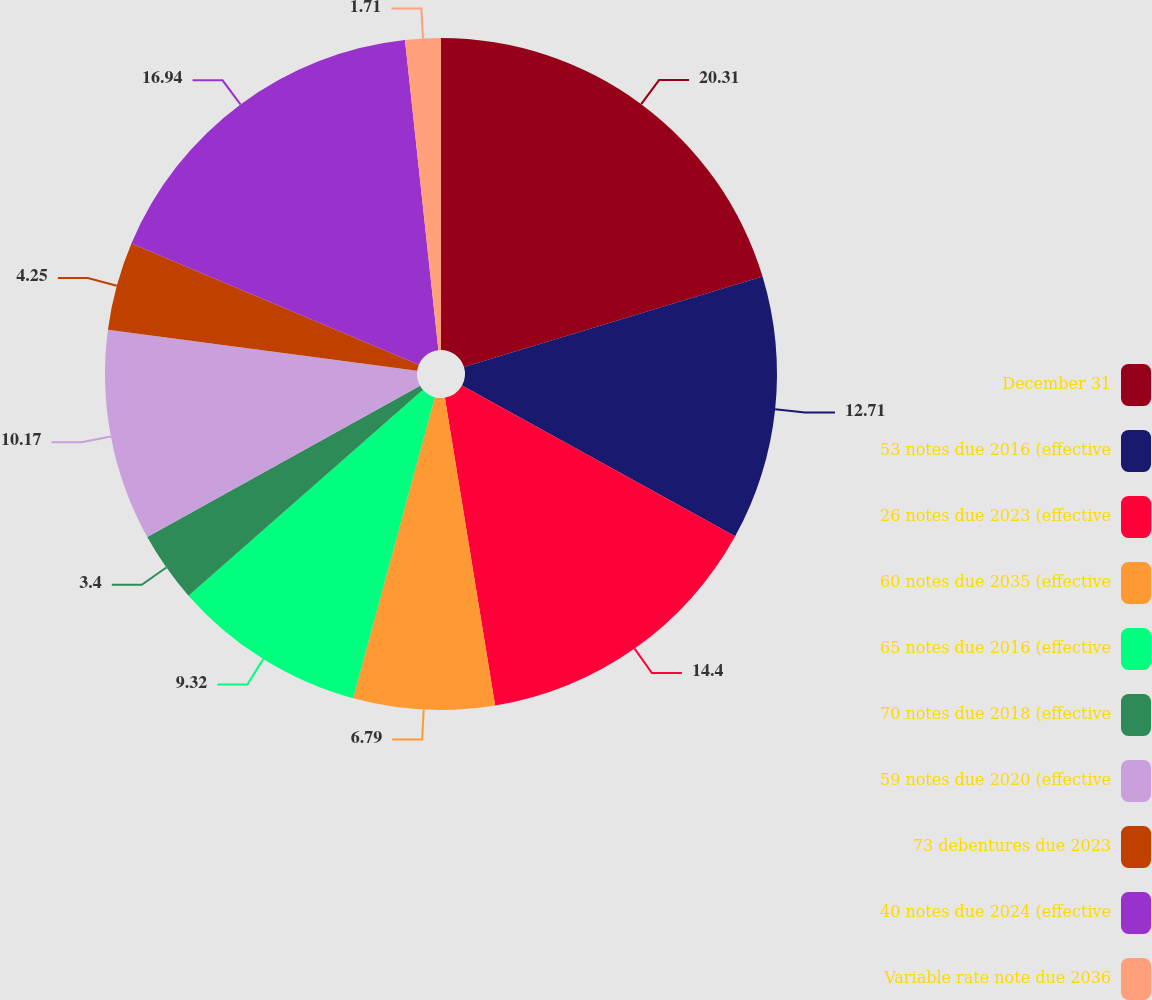<chart> <loc_0><loc_0><loc_500><loc_500><pie_chart><fcel>December 31<fcel>53 notes due 2016 (effective<fcel>26 notes due 2023 (effective<fcel>60 notes due 2035 (effective<fcel>65 notes due 2016 (effective<fcel>70 notes due 2018 (effective<fcel>59 notes due 2020 (effective<fcel>73 debentures due 2023<fcel>40 notes due 2024 (effective<fcel>Variable rate note due 2036<nl><fcel>20.32%<fcel>12.71%<fcel>14.4%<fcel>6.79%<fcel>9.32%<fcel>3.4%<fcel>10.17%<fcel>4.25%<fcel>16.94%<fcel>1.71%<nl></chart> 